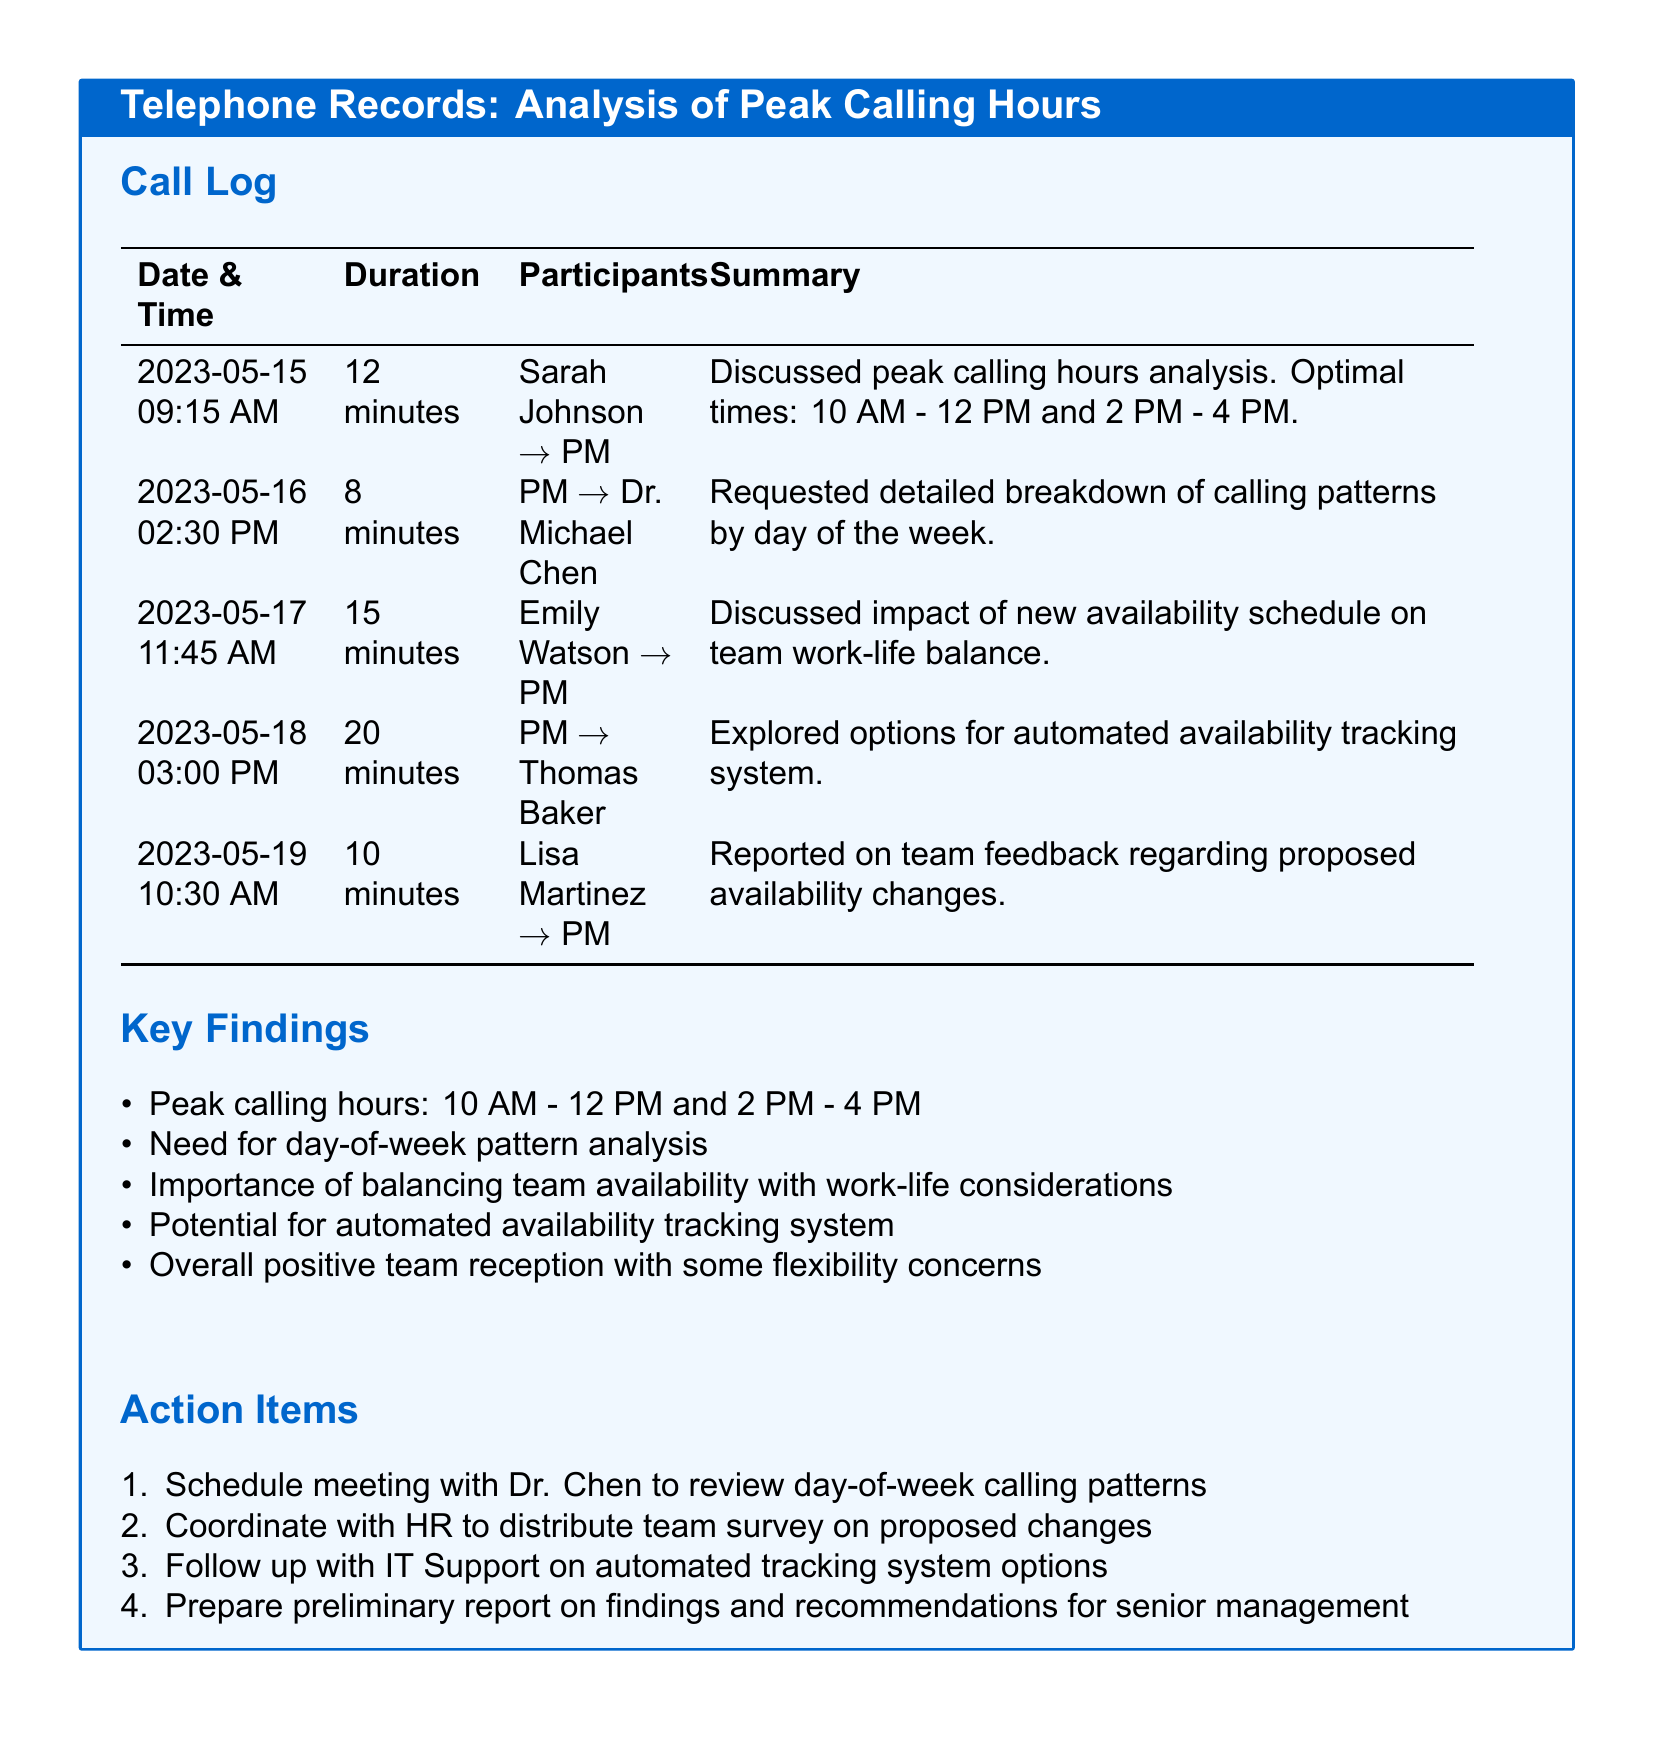What are the peak calling hours? The peak calling hours are identified in the document as the times when calls are most frequently made, which are from 10 AM to 12 PM and 2 PM to 4 PM.
Answer: 10 AM - 12 PM and 2 PM - 4 PM Who led the discussion on peak calling hours analysis? The discussion about peak calling hours analysis was specifically mentioned in the call log involving Sarah Johnson who directed the conversation towards the project manager.
Answer: Sarah Johnson What was the duration of the call between PM and Dr. Michael Chen? The duration of the call is listed in the call log, indicating how long the conversation took place between the project manager and Dr. Michael Chen.
Answer: 8 minutes What is one action item listed in the document? The document includes a list of action items to be completed, among which there are several tasks specifically outlined that need to be followed up on.
Answer: Schedule meeting with Dr. Chen to review day-of-week calling patterns Which participant reported on team feedback regarding proposed availability changes? In the call log, it is noted that Lisa Martinez was the participant who conveyed information related to team feedback on the proposed availability changes.
Answer: Lisa Martinez What is the suggested method for tracking availability mentioned in the document? The document mentions a particular idea or concept regarding monitoring or recording team availability which may involve technological solutions.
Answer: Automated availability tracking system How long was the call between Emily Watson and PM? The call log specifies the duration in minutes for each conversation including the one between Emily Watson and the project manager.
Answer: 15 minutes 